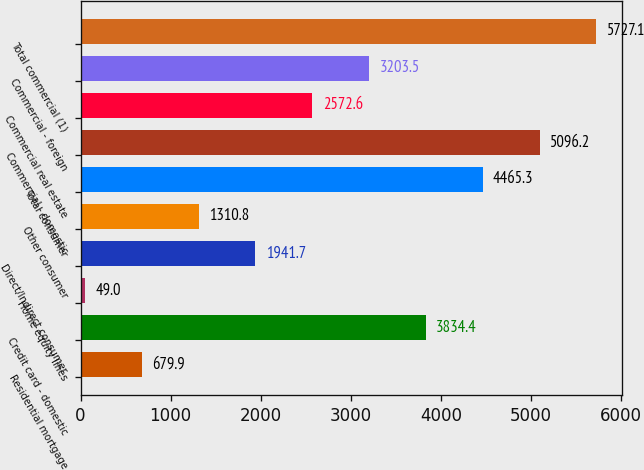Convert chart to OTSL. <chart><loc_0><loc_0><loc_500><loc_500><bar_chart><fcel>Residential mortgage<fcel>Credit card - domestic<fcel>Home equity lines<fcel>Direct/Indirect consumer<fcel>Other consumer<fcel>Total consumer<fcel>Commercial - domestic<fcel>Commercial real estate<fcel>Commercial - foreign<fcel>Total commercial (1)<nl><fcel>679.9<fcel>3834.4<fcel>49<fcel>1941.7<fcel>1310.8<fcel>4465.3<fcel>5096.2<fcel>2572.6<fcel>3203.5<fcel>5727.1<nl></chart> 